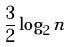<formula> <loc_0><loc_0><loc_500><loc_500>\frac { 3 } { 2 } \log _ { 2 } n</formula> 